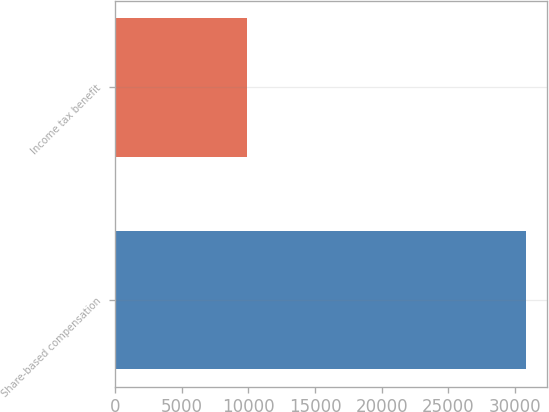Convert chart to OTSL. <chart><loc_0><loc_0><loc_500><loc_500><bar_chart><fcel>Share-based compensation<fcel>Income tax benefit<nl><fcel>30809<fcel>9879<nl></chart> 